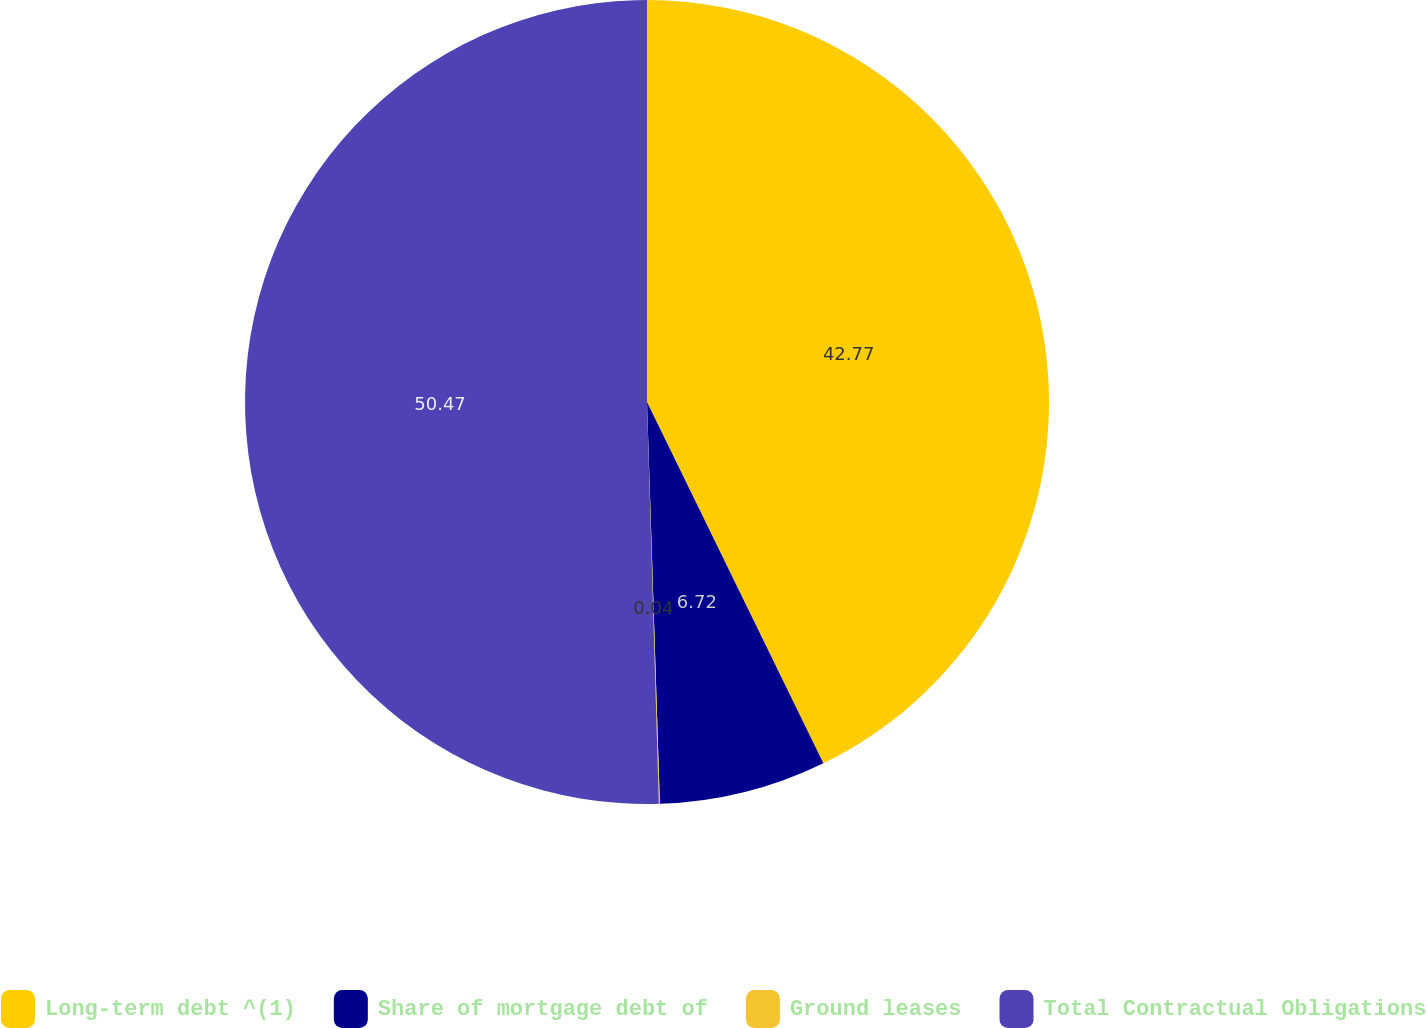Convert chart to OTSL. <chart><loc_0><loc_0><loc_500><loc_500><pie_chart><fcel>Long-term debt ^(1)<fcel>Share of mortgage debt of<fcel>Ground leases<fcel>Total Contractual Obligations<nl><fcel>42.77%<fcel>6.72%<fcel>0.04%<fcel>50.47%<nl></chart> 